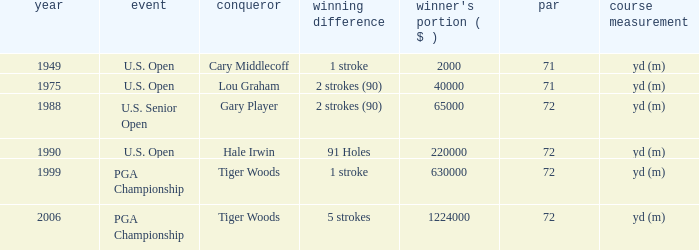When 1999 is the year how many tournaments are there? 1.0. 